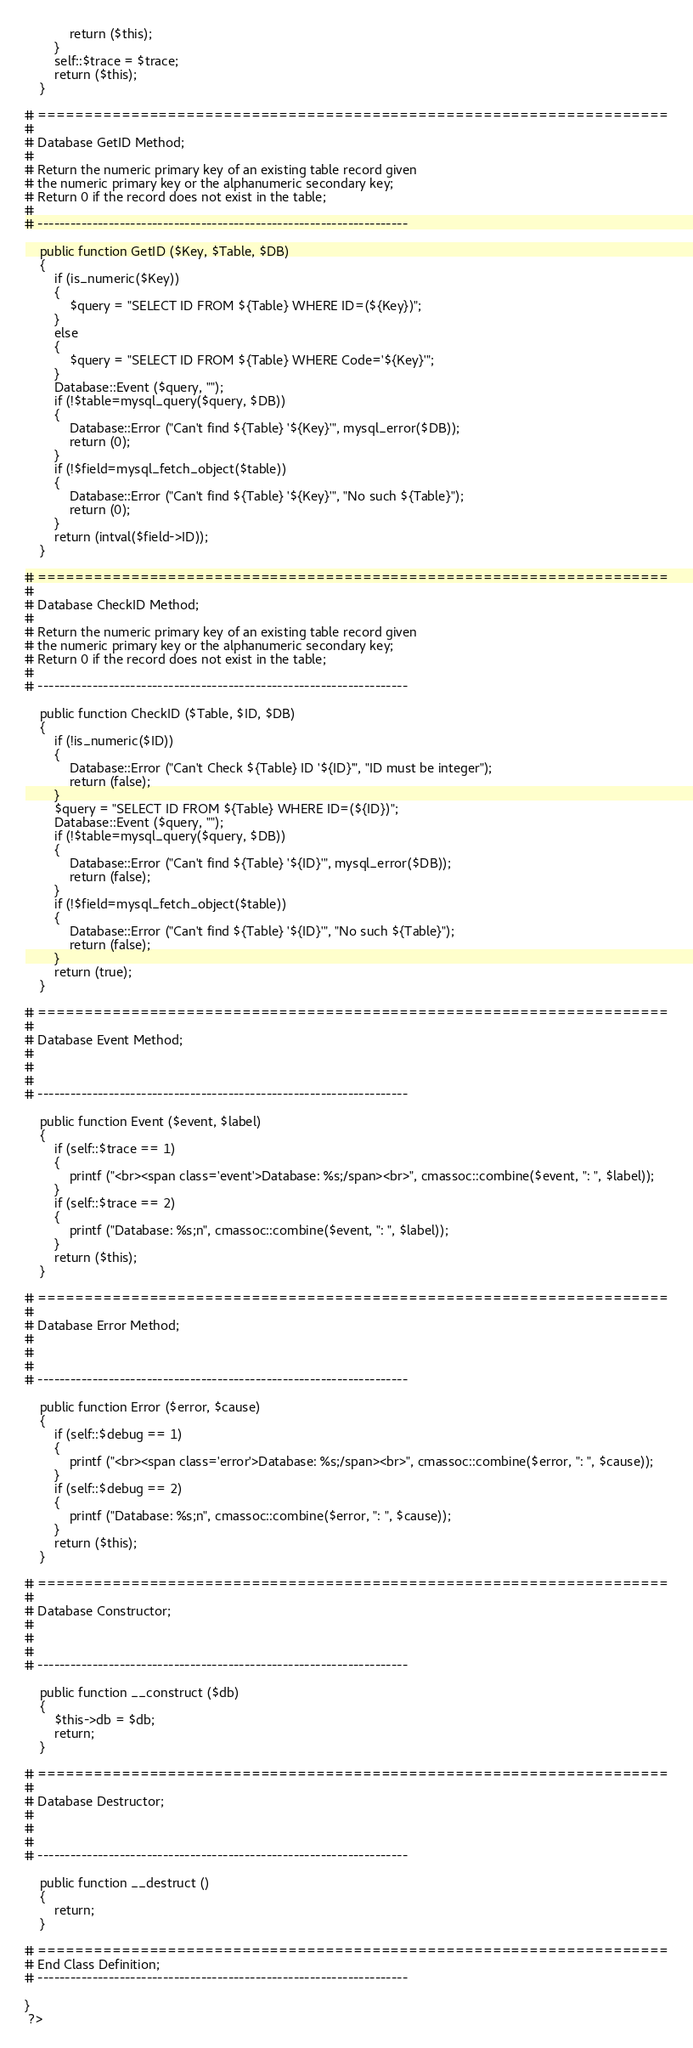<code> <loc_0><loc_0><loc_500><loc_500><_PHP_>			return ($this);
		}
		self::$trace = $trace;
		return ($this);
	}

# ====================================================================
#
# Database GetID Method;
#
# Return the numeric primary key of an existing table record given
# the numeric primary key or the alphanumeric secondary key;
# Return 0 if the record does not exist in the table;
#
# --------------------------------------------------------------------

	public function GetID ($Key, $Table, $DB) 
	{
		if (is_numeric($Key)) 
		{
			$query = "SELECT ID FROM ${Table} WHERE ID=(${Key})";
		}
		else 
		{
			$query = "SELECT ID FROM ${Table} WHERE Code='${Key}'";
		}
		Database::Event ($query, "");
		if (!$table=mysql_query($query, $DB)) 
		{
			Database::Error ("Can't find ${Table} '${Key}'", mysql_error($DB));
			return (0);
		}
		if (!$field=mysql_fetch_object($table)) 
		{
			Database::Error ("Can't find ${Table} '${Key}'", "No such ${Table}");
			return (0);
		}
		return (intval($field->ID));
	}

# ====================================================================
#
# Database CheckID Method;
#
# Return the numeric primary key of an existing table record given
# the numeric primary key or the alphanumeric secondary key;
# Return 0 if the record does not exist in the table;
#
# --------------------------------------------------------------------

	public function CheckID ($Table, $ID, $DB) 
	{
		if (!is_numeric($ID)) 
		{
			Database::Error ("Can't Check ${Table} ID '${ID}'", "ID must be integer");
			return (false);
		}
		$query = "SELECT ID FROM ${Table} WHERE ID=(${ID})";
		Database::Event ($query, "");
		if (!$table=mysql_query($query, $DB)) 
		{
			Database::Error ("Can't find ${Table} '${ID}'", mysql_error($DB));
			return (false);
		}
		if (!$field=mysql_fetch_object($table)) 
		{
			Database::Error ("Can't find ${Table} '${ID}'", "No such ${Table}");
			return (false);
		}
		return (true);
	}

# ====================================================================
#
# Database Event Method;
#
#
#
# --------------------------------------------------------------------

	public function Event ($event, $label) 
	{
		if (self::$trace == 1) 
		{
			printf ("<br><span class='event'>Database: %s;/span><br>", cmassoc::combine($event, ": ", $label));
		}
		if (self::$trace == 2) 
		{
			printf ("Database: %s;n", cmassoc::combine($event, ": ", $label));
		}
		return ($this);
	}

# ====================================================================
#
# Database Error Method;
#
#
#
# --------------------------------------------------------------------

	public function Error ($error, $cause) 
	{
		if (self::$debug == 1) 
		{
			printf ("<br><span class='error'>Database: %s;/span><br>", cmassoc::combine($error, ": ", $cause));
		}
		if (self::$debug == 2) 
		{
			printf ("Database: %s;n", cmassoc::combine($error, ": ", $cause));
		}
		return ($this);
	}

# ====================================================================
#
# Database Constructor;
#
#
#
# --------------------------------------------------------------------

	public function __construct ($db) 
	{
		$this->db = $db;
		return;
	}

# ====================================================================
#
# Database Destructor;
#
#
#
# --------------------------------------------------------------------

	public function __destruct () 
	{
		return;
	}

# ====================================================================
# End Class Definition;
# --------------------------------------------------------------------

}
 ?>
</code> 